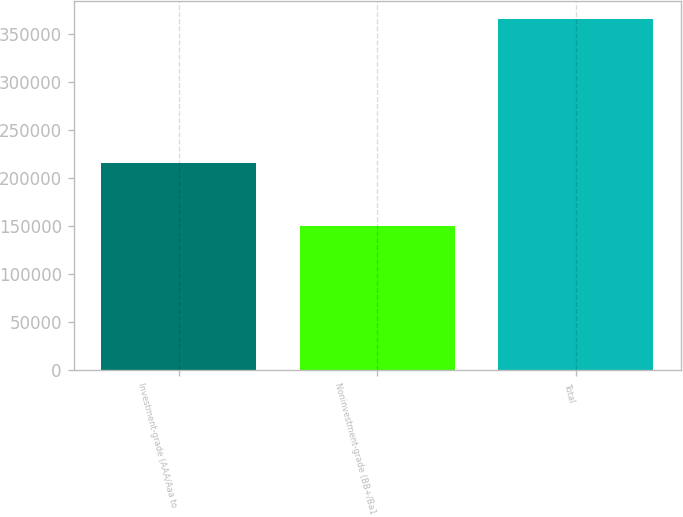<chart> <loc_0><loc_0><loc_500><loc_500><bar_chart><fcel>Investment-grade (AAA/Aaa to<fcel>Noninvestment-grade (BB+/Ba1<fcel>Total<nl><fcel>215580<fcel>150122<fcel>365702<nl></chart> 